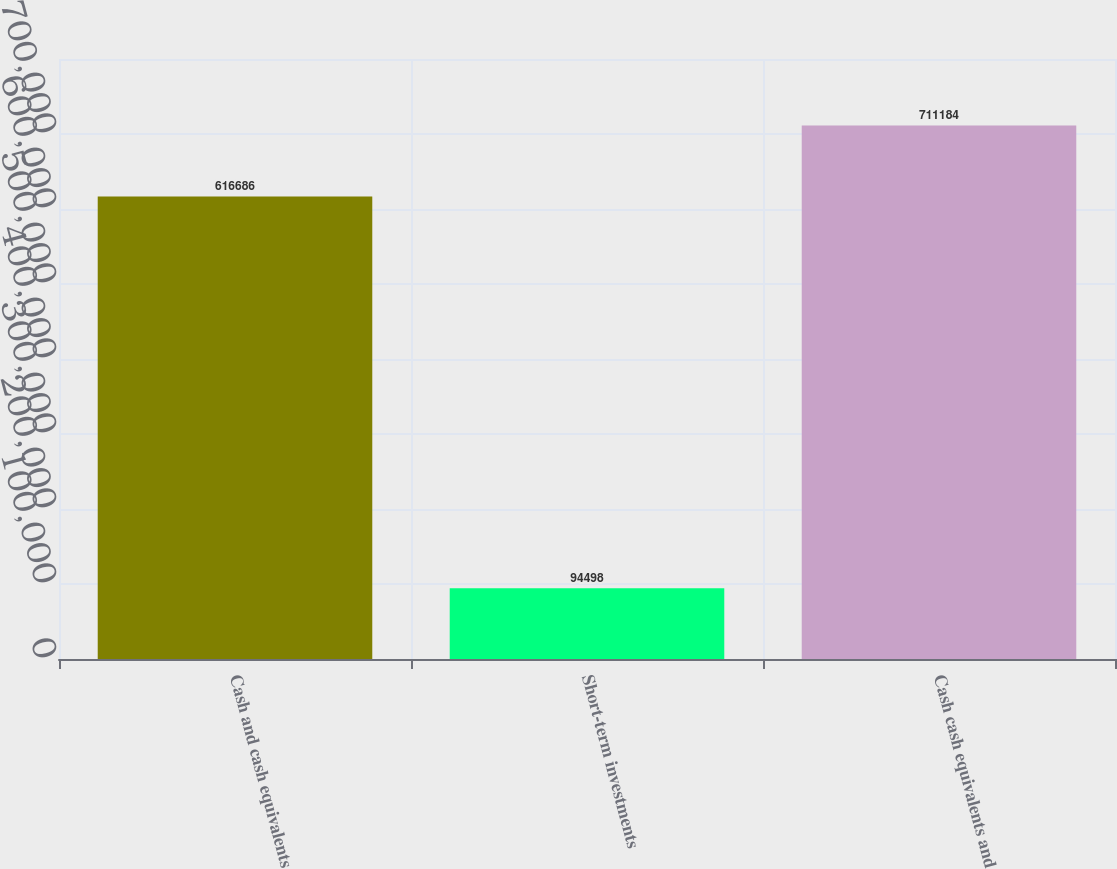<chart> <loc_0><loc_0><loc_500><loc_500><bar_chart><fcel>Cash and cash equivalents<fcel>Short-term investments<fcel>Cash cash equivalents and<nl><fcel>616686<fcel>94498<fcel>711184<nl></chart> 